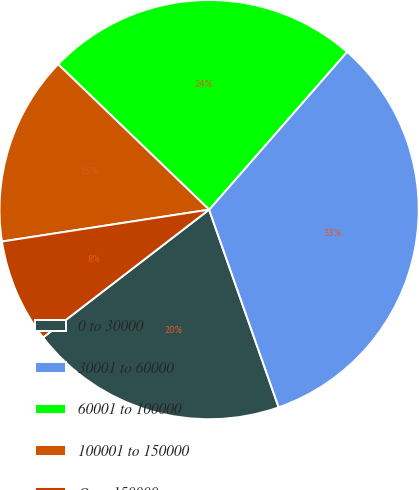Convert chart to OTSL. <chart><loc_0><loc_0><loc_500><loc_500><pie_chart><fcel>0 to 30000<fcel>30001 to 60000<fcel>60001 to 100000<fcel>100001 to 150000<fcel>Over 150000<nl><fcel>19.94%<fcel>33.18%<fcel>24.23%<fcel>14.63%<fcel>8.01%<nl></chart> 